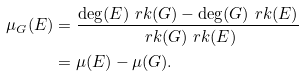Convert formula to latex. <formula><loc_0><loc_0><loc_500><loc_500>\mu _ { G } ( E ) & = \frac { \deg ( E ) \ r k ( G ) - \deg ( G ) \ r k ( E ) } { \ r k ( G ) \ r k ( E ) } \\ & = \mu ( E ) - \mu ( G ) .</formula> 